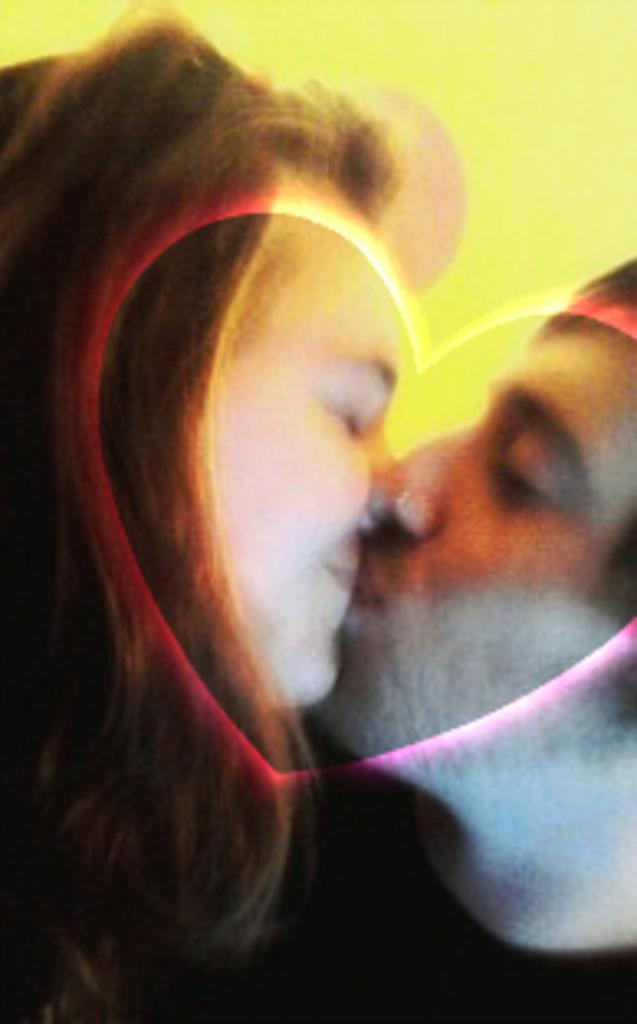How many people are present in the image? There is a man and a woman present in the image. What are the man and woman doing in the image? The man and woman are kissing each other in the image. What type of art style is used in the image? The image features animation. What color is the background of the image? The background of the image is yellow in color. What type of beast can be seen in the image? There is no beast present in the image; it features a man and a woman kissing each other. How does the heat affect the man and woman in the image? The image does not depict any heat or temperature changes, so it cannot be determined how it affects the man and woman. 